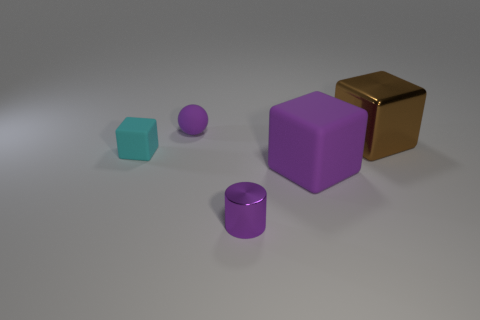What number of things are purple matte blocks on the right side of the small purple sphere or large blue matte cylinders?
Offer a very short reply. 1. Are there fewer brown things that are behind the large brown metallic object than cyan rubber things that are on the right side of the purple metallic cylinder?
Your response must be concise. No. What number of other objects are there of the same size as the purple ball?
Offer a terse response. 2. Is the purple sphere made of the same material as the thing to the right of the large purple cube?
Keep it short and to the point. No. How many objects are small purple metal things that are in front of the big brown object or things that are in front of the purple cube?
Make the answer very short. 1. What color is the small cylinder?
Keep it short and to the point. Purple. Are there fewer big brown metallic objects to the left of the big metallic block than balls?
Give a very brief answer. Yes. Is there anything else that has the same shape as the large brown thing?
Give a very brief answer. Yes. Are there any tiny cylinders?
Provide a succinct answer. Yes. Is the number of small cyan metal cubes less than the number of big brown objects?
Your response must be concise. Yes. 